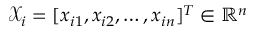<formula> <loc_0><loc_0><loc_500><loc_500>\mathcal { X } _ { i } = [ x _ { i 1 } , x _ { i 2 } , \dots , x _ { i n } ] ^ { T } \in \mathbb { R } ^ { n }</formula> 